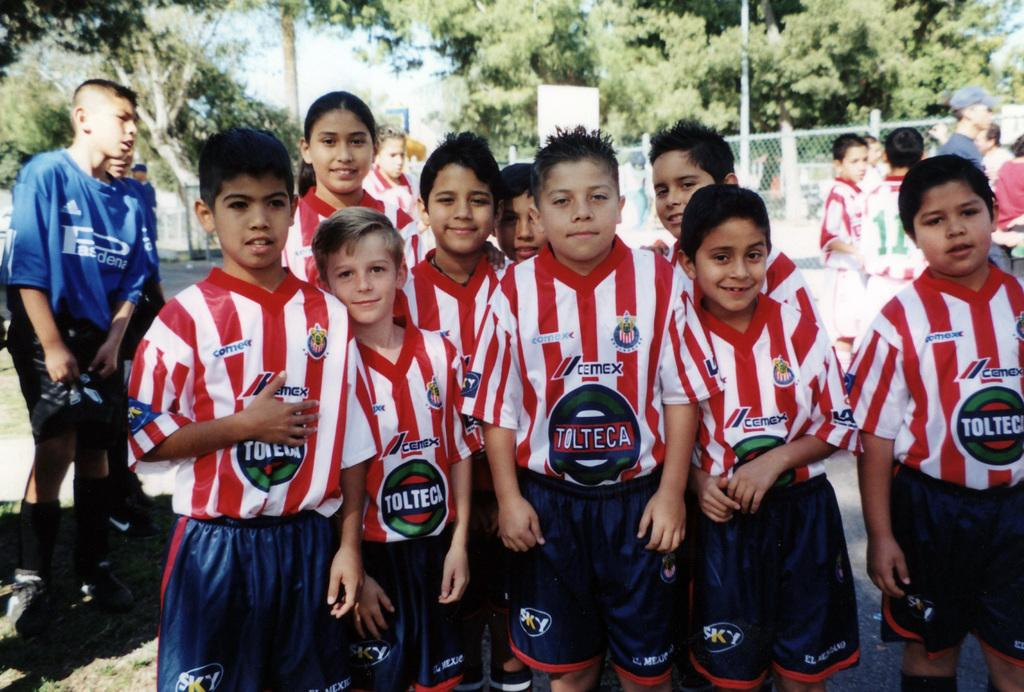<image>
Present a compact description of the photo's key features. The team of young boys pictured are sponsored by Tolteca. 